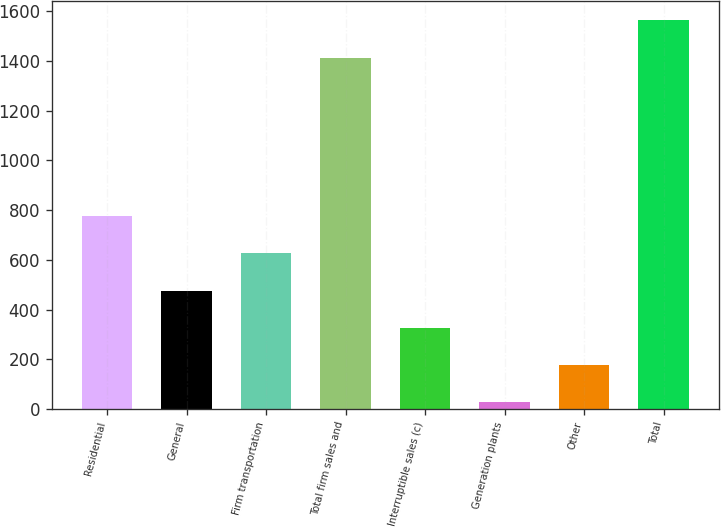Convert chart. <chart><loc_0><loc_0><loc_500><loc_500><bar_chart><fcel>Residential<fcel>General<fcel>Firm transportation<fcel>Total firm sales and<fcel>Interruptible sales (c)<fcel>Generation plants<fcel>Other<fcel>Total<nl><fcel>776.5<fcel>476.3<fcel>626.4<fcel>1414<fcel>326.2<fcel>26<fcel>176.1<fcel>1564.1<nl></chart> 